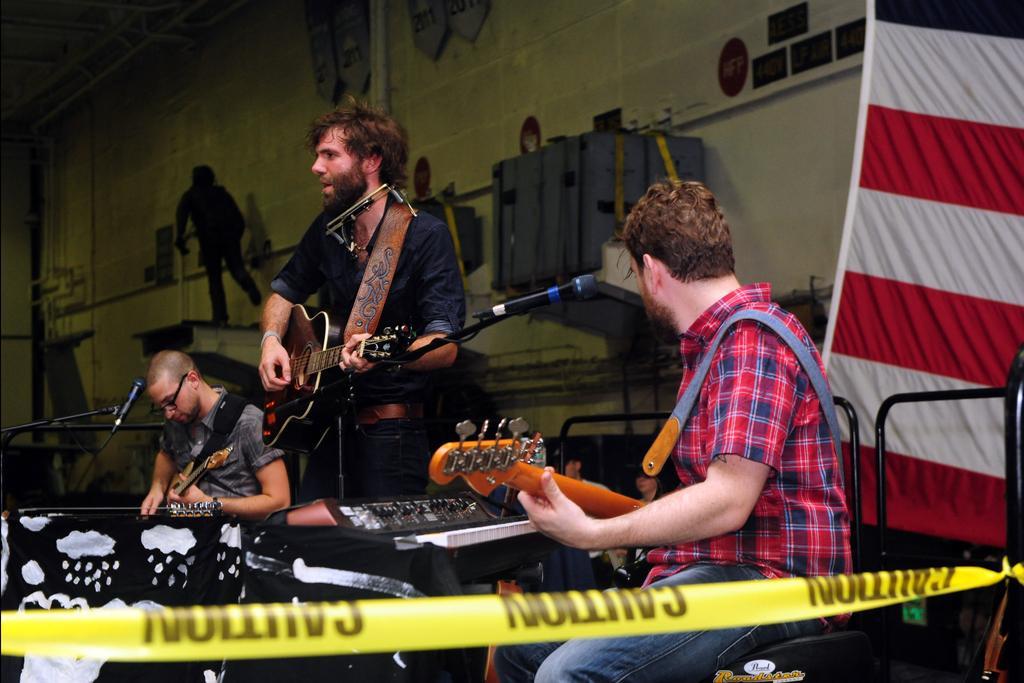How would you summarize this image in a sentence or two? There are three persons playing guitar in front of a mic. 